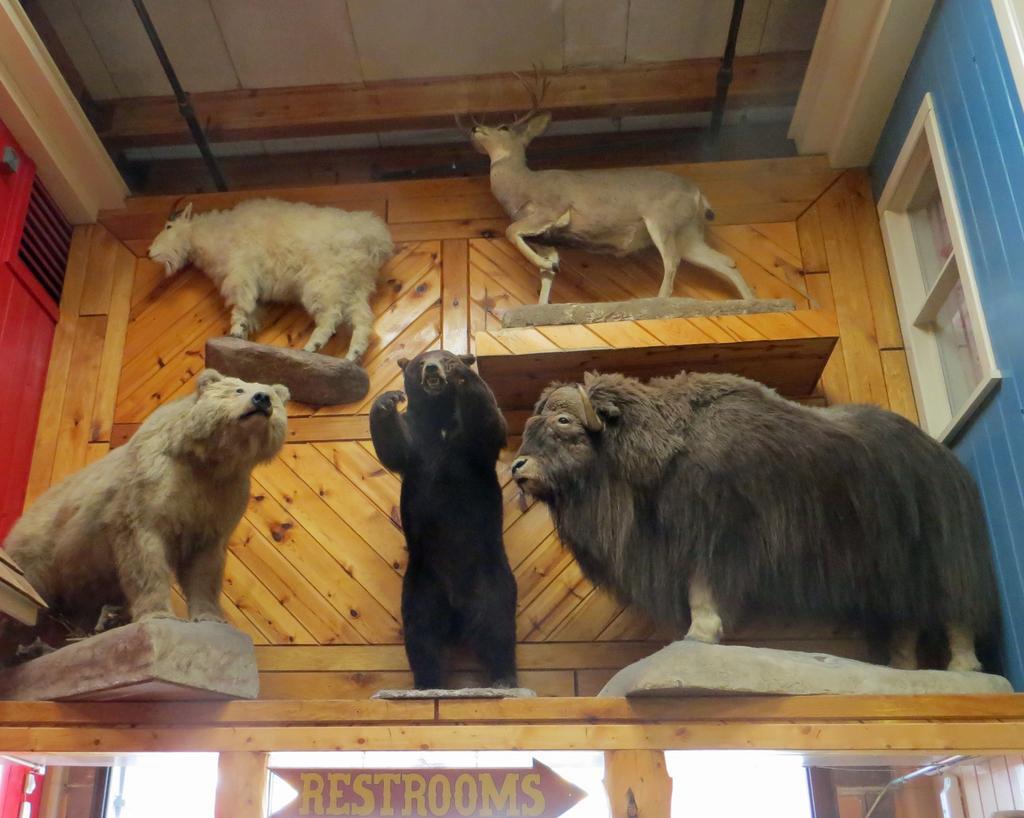Can you describe this image briefly? In the picture we can see some animal statues are placed on the wooden plank and behind it, we can see a wooden wall and under the wooden plank we can see a name restrooms, and to the ceiling also we can see a wooden plank and into the wall we can see a window with a glass. 